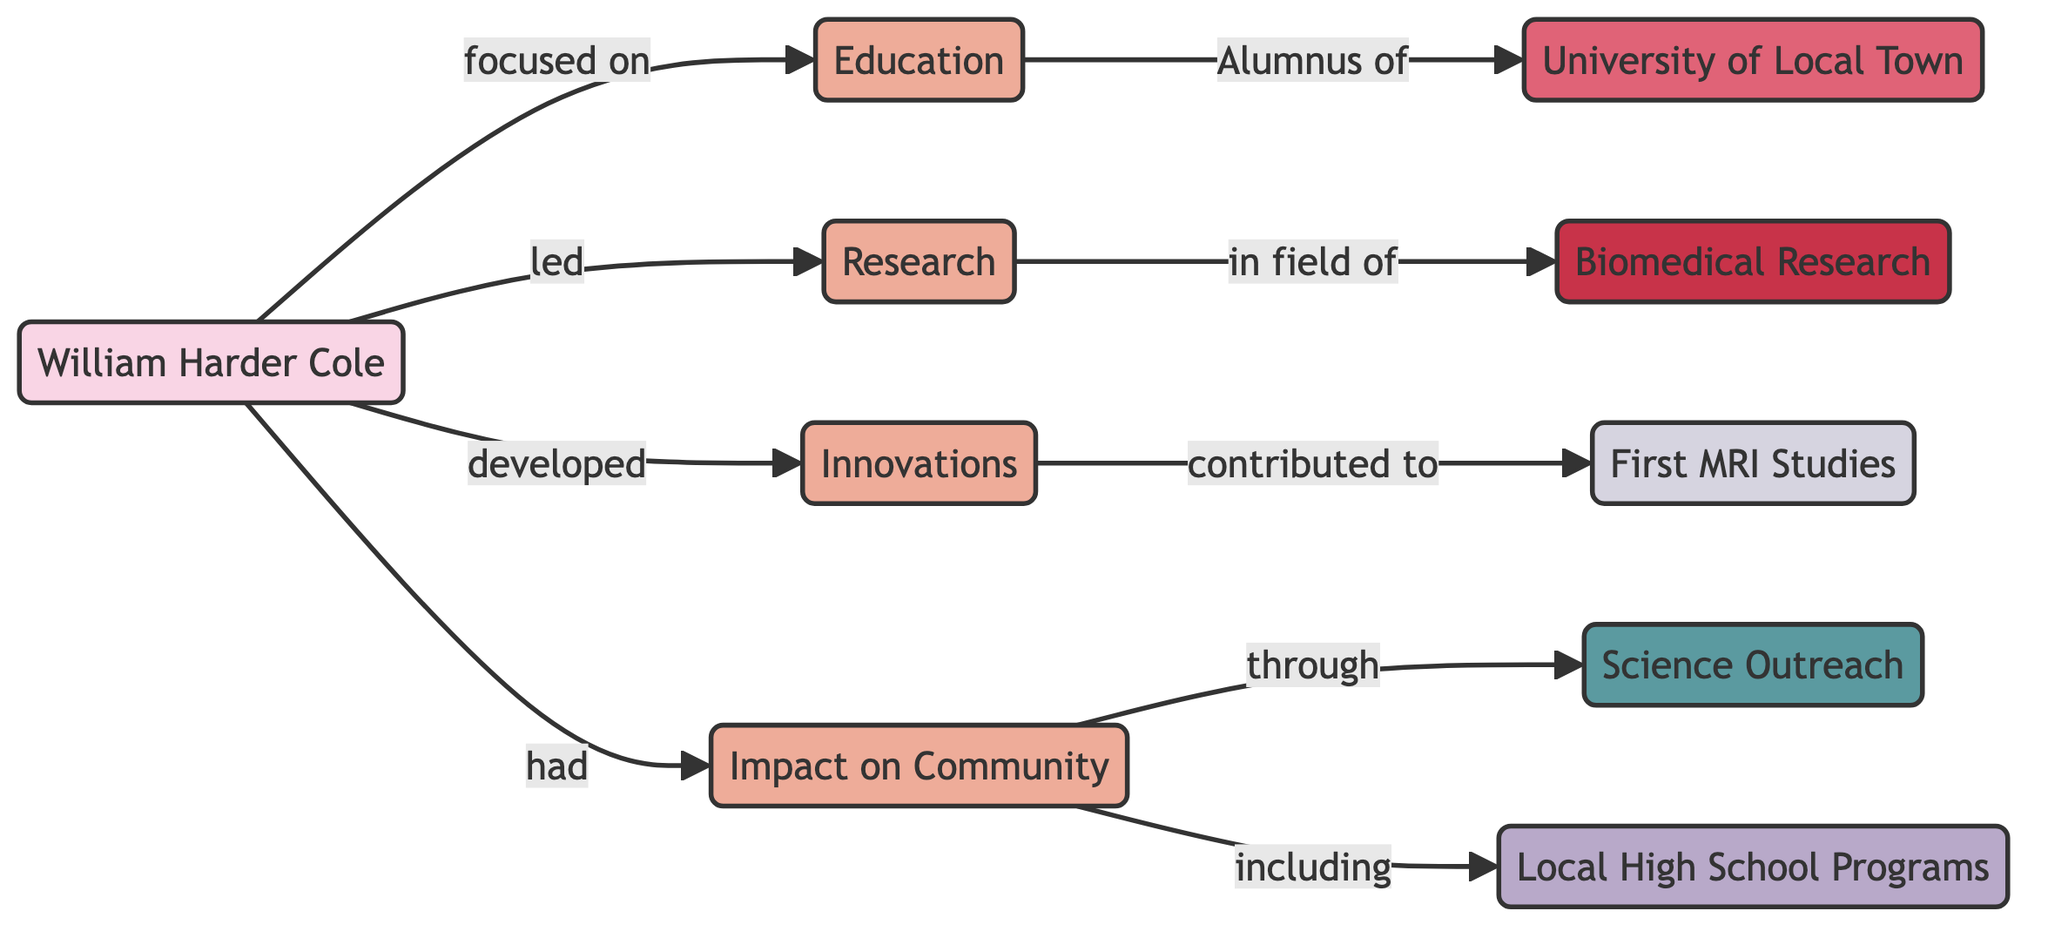What is William Harder Cole's primary focus? The diagram indicates that William Harder Cole is primarily focused on education, as shown in the first connection from WHC to ED.
Answer: Education Which university is William Harder Cole an alumnus of? The diagram specifies that William Harder Cole is an alumnus of the University of Local Town, which is connected directly to the education node.
Answer: University of Local Town What milestone is connected to the innovations developed by William Harder Cole? The milestone connected to the innovations developed by William Harder Cole is the First MRI Studies, indicated by the link between the innovations and the milestone nodes.
Answer: First MRI Studies How does William Harder Cole impact the community? It is shown in the diagram that William Harder Cole impacts the community through science outreach, which is directly connected to the impact on the community node.
Answer: Science Outreach What field of research did William Harder Cole lead? The diagram illustrates that William Harder Cole led research in the field of biomedical research, as indicated by the connection between the research and the field nodes.
Answer: Biomedical Research What program is included in William Harder Cole's community impact? The diagram shows that Local High School Programs are part of William Harder Cole's impact on the community, as indicated by the connection from "Impact on Community" to the program node.
Answer: Local High School Programs How many attributes are associated with William Harder Cole? The diagram presents four attributes connected to William Harder Cole: Education, Research, Innovations, and Impact on Community, thus there are a total of four attributes associated with him.
Answer: Four What is the relationship between the developments made by William Harder Cole and the First MRI Studies? The relationship is that the innovations developed by William Harder Cole contributed to the First MRI Studies, as indicated by the arrow leading from innovations to the milestone node.
Answer: Contributed to Which activity is William Harder Cole involved in concerning his impact on the community? The activity that William Harder Cole is involved in concerning his impact on the community is Science Outreach, as indicated in the flow from the impact node to the activity node.
Answer: Science Outreach 